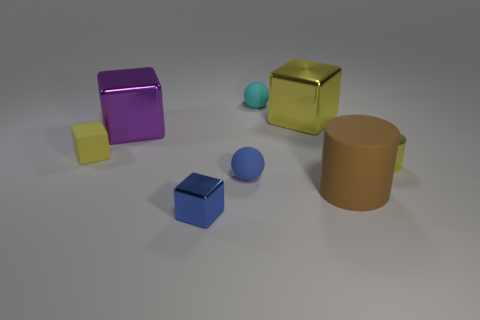Is the material of the big purple cube the same as the tiny yellow block?
Offer a very short reply. No. The large brown matte object has what shape?
Ensure brevity in your answer.  Cylinder. There is a object that is behind the metal cube that is on the right side of the blue shiny cube; what number of cyan rubber things are in front of it?
Your answer should be very brief. 0. The other large object that is the same shape as the large yellow shiny object is what color?
Your response must be concise. Purple. There is a tiny blue thing that is in front of the big thing that is in front of the metallic thing that is on the right side of the big brown cylinder; what is its shape?
Provide a short and direct response. Cube. There is a metal object that is both in front of the large purple metallic block and behind the rubber cylinder; how big is it?
Offer a terse response. Small. Are there fewer cubes than things?
Offer a very short reply. Yes. There is a yellow rubber object that is on the left side of the large brown cylinder; what is its size?
Your response must be concise. Small. What is the shape of the metal object that is both left of the tiny cyan rubber sphere and behind the large cylinder?
Your answer should be very brief. Cube. The other matte thing that is the same shape as the blue rubber thing is what size?
Keep it short and to the point. Small. 